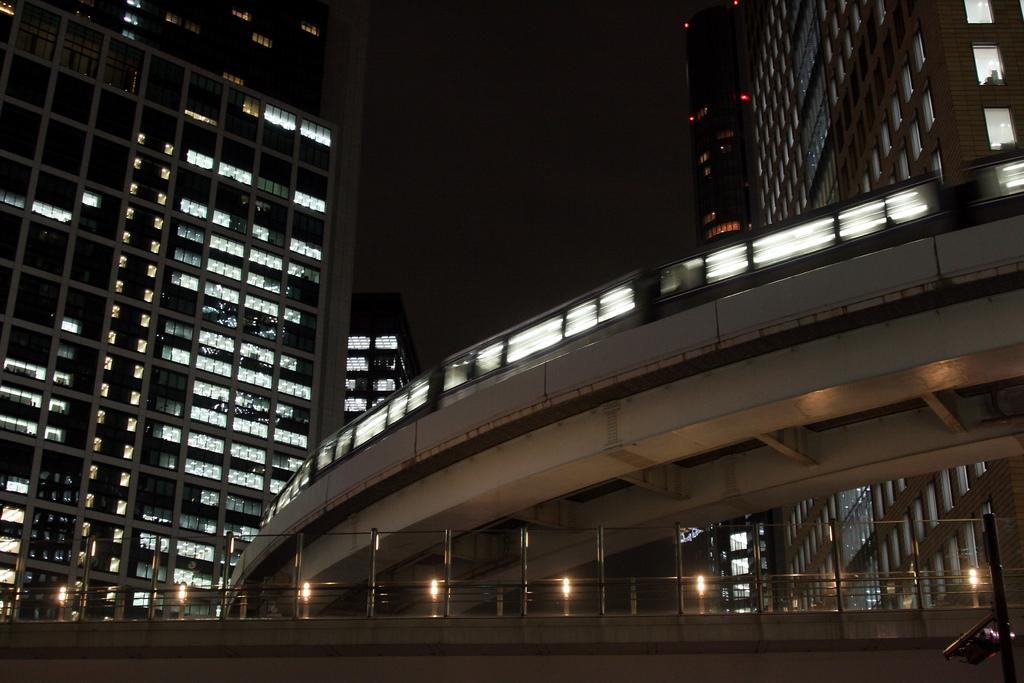What type of structures can be seen in the image? There are buildings in the image. What else is visible in the image besides the buildings? There are lights and iron rods visible in the image. Can you describe the transportation feature in the image? A: There is a train on a bridge in the image. What part of the train is being kicked in the image? There is no indication in the image that any part of the train is being kicked. 